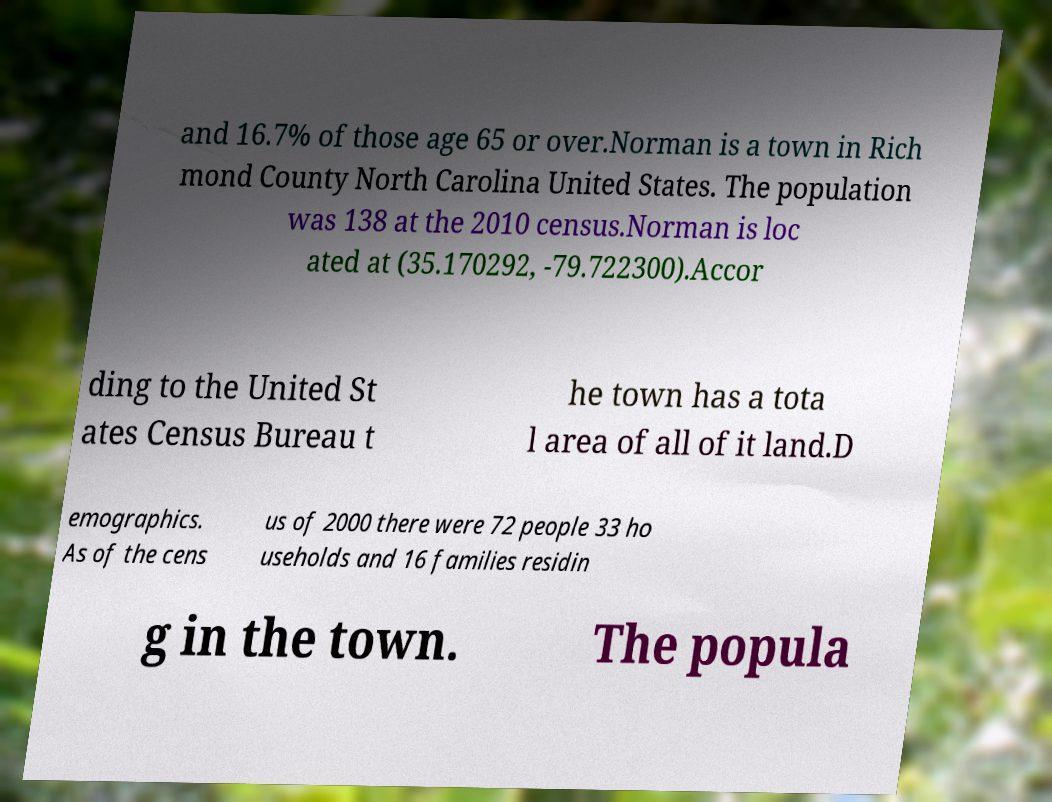Please identify and transcribe the text found in this image. and 16.7% of those age 65 or over.Norman is a town in Rich mond County North Carolina United States. The population was 138 at the 2010 census.Norman is loc ated at (35.170292, -79.722300).Accor ding to the United St ates Census Bureau t he town has a tota l area of all of it land.D emographics. As of the cens us of 2000 there were 72 people 33 ho useholds and 16 families residin g in the town. The popula 